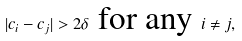Convert formula to latex. <formula><loc_0><loc_0><loc_500><loc_500>| c _ { i } - c _ { j } | > 2 \delta \ \text {for any} \ i \neq j ,</formula> 